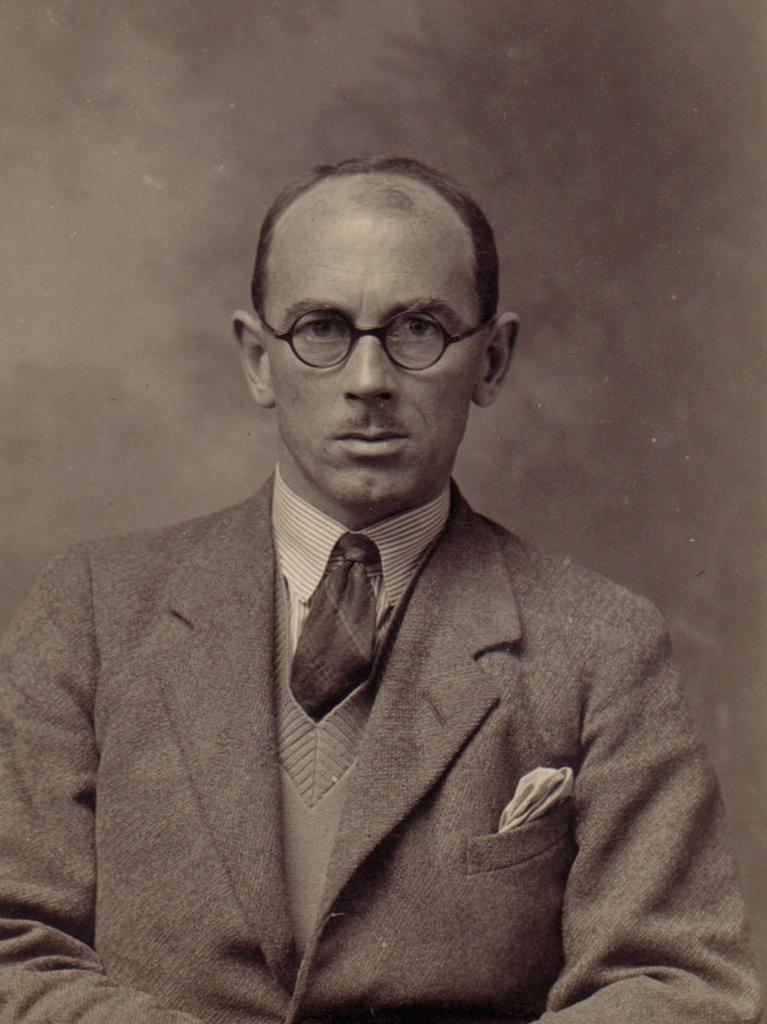Who or what is present in the image? There is a person in the image. What is the person wearing? The person is wearing a suit, a tie, and spectacles. What can be seen behind the person? There is a wall behind the person. What type of wax is being used by the person in the image? There is no mention of wax in the image, so it cannot be determined if any wax is being used. 